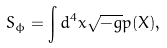<formula> <loc_0><loc_0><loc_500><loc_500>S _ { \phi } = \int d ^ { 4 } x \sqrt { - g } p ( X ) ,</formula> 